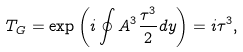Convert formula to latex. <formula><loc_0><loc_0><loc_500><loc_500>T _ { G } = \exp \left ( i \oint A ^ { 3 } \frac { \tau ^ { 3 } } { 2 } d y \right ) = i \tau ^ { 3 } ,</formula> 